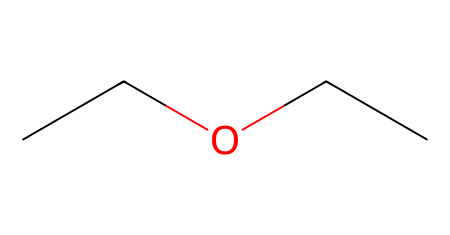What is the name of this chemical? The SMILES representation "CCOCC" corresponds to a molecule known as ethoxyethane, which is a common name for diethyl ether.
Answer: ethoxyethane How many carbon atoms are in the molecule? Counting the "C" symbols in the SMILES, there are four carbon atoms total: two from each "CC" string.
Answer: four What type of chemical bond primarily connects the atoms in this ether? The structure consists of single bonds between carbon and hydrogen atoms, and carbon and oxygen atoms, indicative of covalent bonding.
Answer: covalent What is the functional group present in this chemical? The structure contains an ether functional group represented by the oxygen atom bonded to two carbon groups.
Answer: ether Which part of this chemical indicates it is an ether? The presence of the oxygen atom bonded to two alkyl (ethyl) groups (C-C) showcases the ether functional group characteristic.
Answer: oxygen atom What is the molecular formula for ethoxyethane? To derive the formula, we need to sum all the atoms: C4, H10, and O1 leads to the molecular formula C4H10O.
Answer: C4H10O How many hydrogen atoms does ethoxyethane contain? From the structure, two ethyl (C2H5) groups contribute a total of 10 hydrogen atoms combined (5 from each).
Answer: ten 